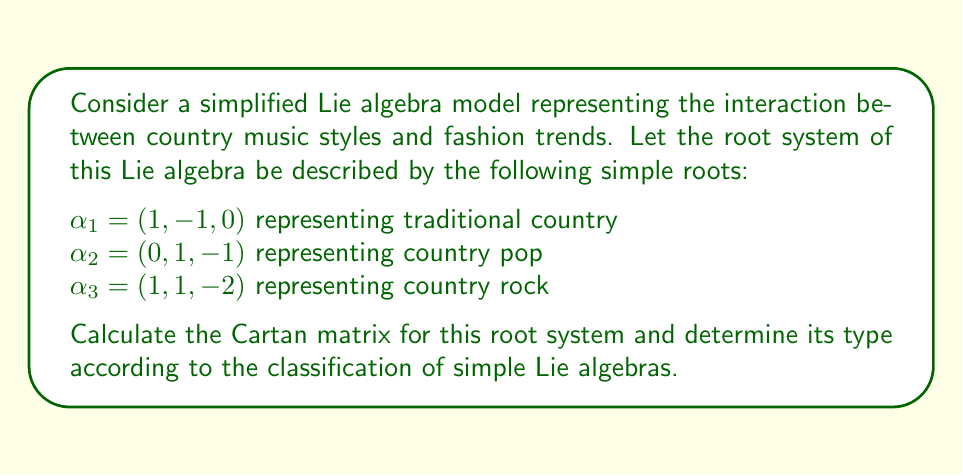Can you solve this math problem? To solve this problem, we need to follow these steps:

1) First, we need to calculate the Cartan matrix. The Cartan matrix $A = (a_{ij})$ is defined by:

   $a_{ij} = \frac{2(\alpha_i, \alpha_j)}{(\alpha_j, \alpha_j)}$

   where $(\alpha_i, \alpha_j)$ denotes the inner product of roots $\alpha_i$ and $\alpha_j$.

2) Let's calculate the inner products:

   $(\alpha_1, \alpha_1) = 1^2 + (-1)^2 + 0^2 = 2$
   $(\alpha_2, \alpha_2) = 0^2 + 1^2 + (-1)^2 = 2$
   $(\alpha_3, \alpha_3) = 1^2 + 1^2 + (-2)^2 = 6$

   $(\alpha_1, \alpha_2) = 1 \cdot 0 + (-1) \cdot 1 + 0 \cdot (-1) = -1$
   $(\alpha_1, \alpha_3) = 1 \cdot 1 + (-1) \cdot 1 + 0 \cdot (-2) = 0$
   $(\alpha_2, \alpha_3) = 0 \cdot 1 + 1 \cdot 1 + (-1) \cdot (-2) = 3$

3) Now we can calculate the Cartan matrix:

   $a_{11} = \frac{2(2)}{2} = 2$
   $a_{22} = \frac{2(2)}{2} = 2$
   $a_{33} = \frac{2(6)}{6} = 2$

   $a_{12} = \frac{2(-1)}{2} = -1$
   $a_{21} = \frac{2(-1)}{2} = -1$

   $a_{13} = \frac{2(0)}{6} = 0$
   $a_{31} = \frac{2(0)}{2} = 0$

   $a_{23} = \frac{2(3)}{6} = 1$
   $a_{32} = \frac{2(3)}{2} = 3$

4) The Cartan matrix is therefore:

   $$A = \begin{pmatrix}
   2 & -1 & 0 \\
   -1 & 2 & 1 \\
   0 & 3 & 2
   \end{pmatrix}$$

5) To determine the type of this Lie algebra, we need to compare this Cartan matrix with the standard Cartan matrices of simple Lie algebras. This matrix corresponds to the $G_2$ type in the classification of simple Lie algebras.

The $G_2$ type is a 14-dimensional exceptional Lie algebra, which interestingly reflects the complex interplay between country music styles and fashion trends, symbolizing the intricate and sometimes unexpected connections between these cultural elements.
Answer: The Cartan matrix is:

$$A = \begin{pmatrix}
2 & -1 & 0 \\
-1 & 2 & 1 \\
0 & 3 & 2
\end{pmatrix}$$

The root system corresponds to the $G_2$ type in the classification of simple Lie algebras. 